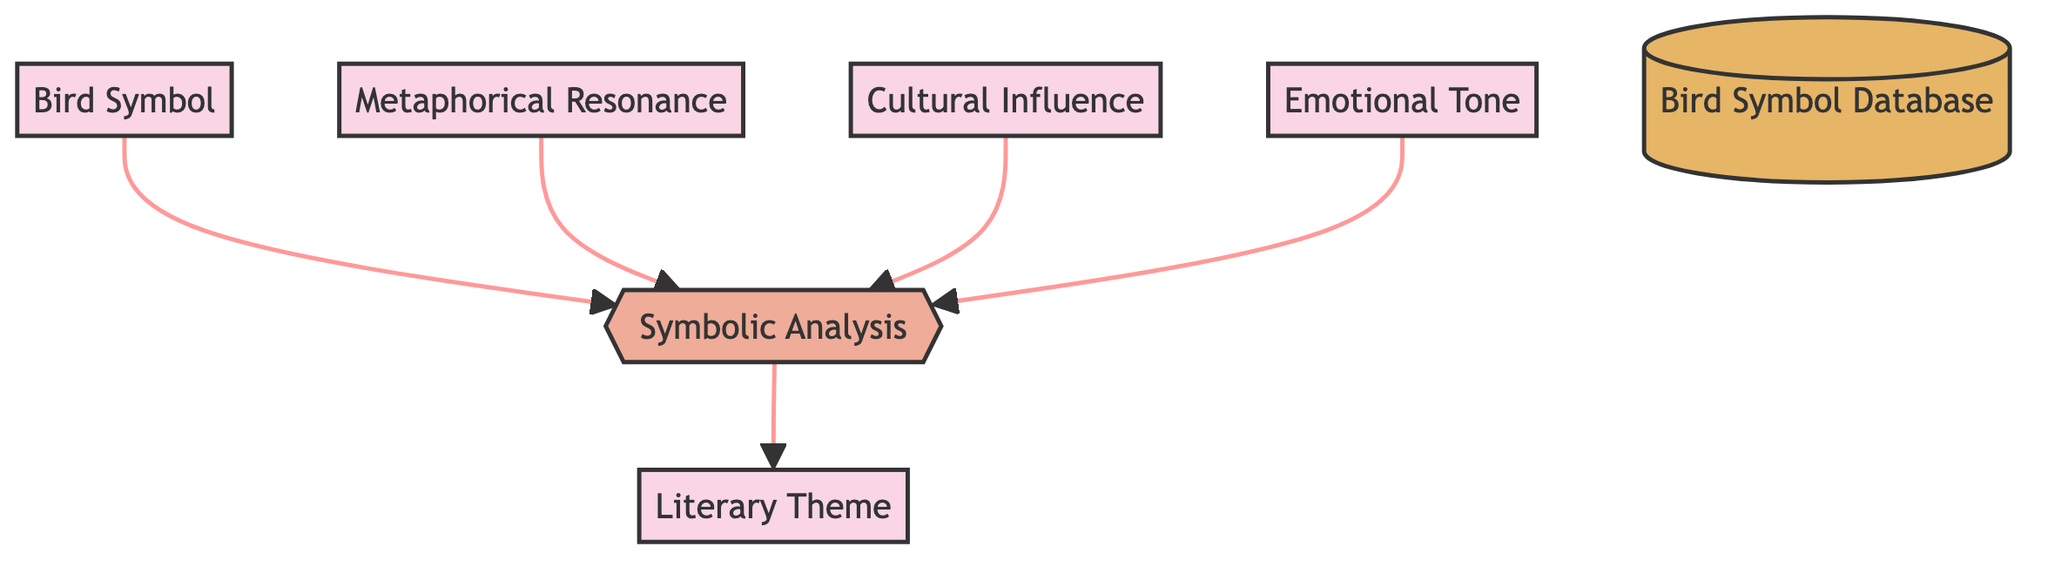What are the four inputs to the Symbolic Analysis process? The inputs to the Symbolic Analysis process are Bird Symbol, Metaphorical Resonance, Cultural Influence, and Emotional Tone. These inputs are clearly listed entering the Symbolic Analysis process in the diagram.
Answer: Bird Symbol, Metaphorical Resonance, Cultural Influence, Emotional Tone How many entities are present in the diagram? There are five entities in the diagram: Bird Symbol, Metaphorical Resonance, Cultural Influence, Emotional Tone, and Literary Theme. This can be counted from the entity section of the diagram.
Answer: 5 What is the output of the Symbolic Analysis process? The output of the Symbolic Analysis process is the connections to Literary Theme. This is explicitly shown as the destination of the flow coming from the Symbolic Analysis process.
Answer: Literary Theme connections What does the flow from the Metaphorical Resonance represent? The flow from the Metaphorical Resonance represents the flow of metaphorical meanings for analysis. This is indicated as a specific input to the Symbolic Analysis process in the diagram.
Answer: Flow of metaphorical meanings Which entity is the data store in this diagram? The data store in this diagram is the Bird Symbol Database. This entity is identified by the notation used for data stores, which is highlighted distinctly in the diagram.
Answer: Bird Symbol Database How many data flows connect to the Symbolic Analysis process? There are four data flows that connect to the Symbolic Analysis process, sourced from Bird Symbol, Metaphorical Resonance, Cultural Influence, and Emotional Tone. This can be counted by examining the arrows pointing towards Symbolic Analysis.
Answer: 4 What is the purpose of the Symbolic Analysis process? The purpose of the Symbolic Analysis process is to analyze bird symbols and map connections to literary themes. This description is specifically provided in the process node itself in the diagram.
Answer: Analyzes bird symbols and maps connections to literary themes What type of diagram is represented here? This diagram is a Data Flow Diagram. The characteristics of the diagram, including entities, processes, and data flows, align with the standard structure of a Data Flow Diagram.
Answer: Data Flow Diagram 